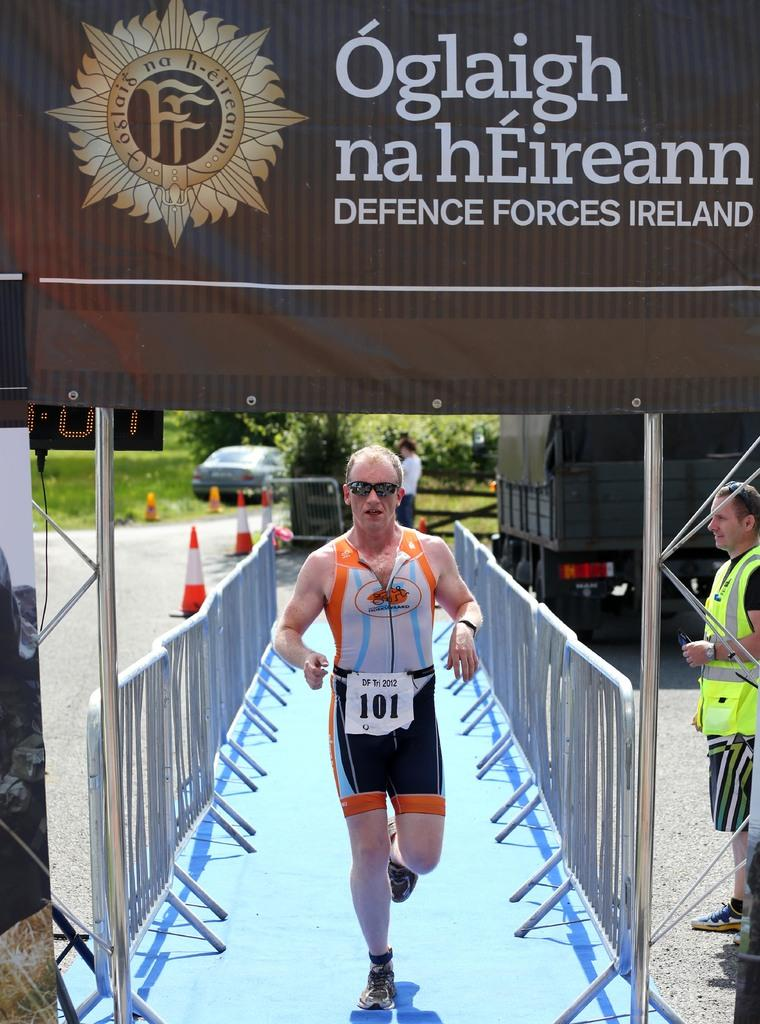<image>
Render a clear and concise summary of the photo. a person that has the number 101 on their paper 